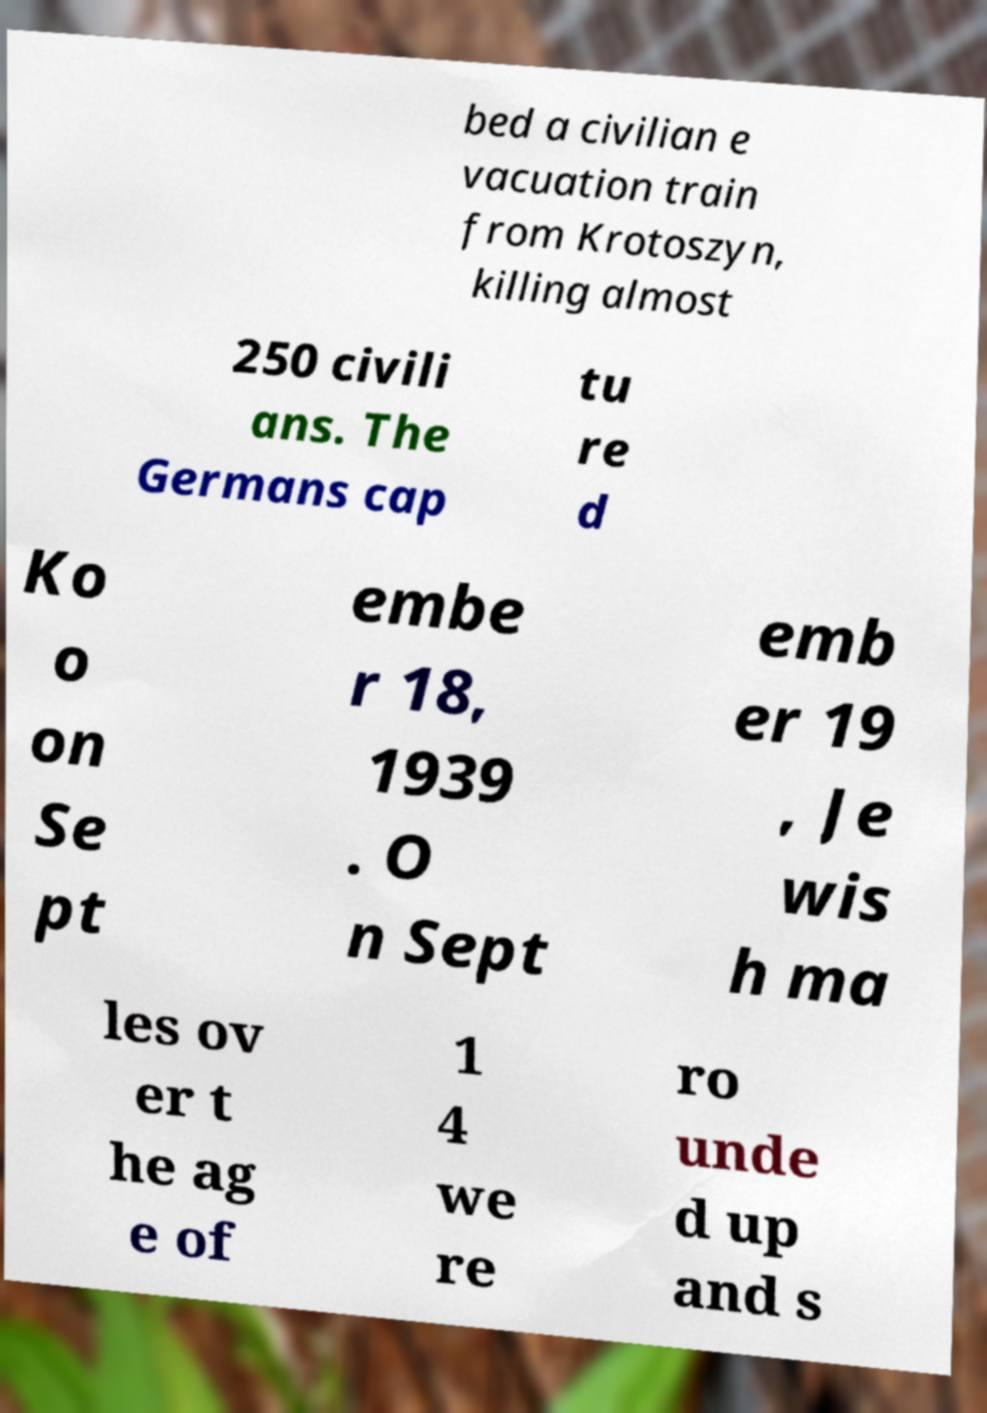For documentation purposes, I need the text within this image transcribed. Could you provide that? bed a civilian e vacuation train from Krotoszyn, killing almost 250 civili ans. The Germans cap tu re d Ko o on Se pt embe r 18, 1939 . O n Sept emb er 19 , Je wis h ma les ov er t he ag e of 1 4 we re ro unde d up and s 